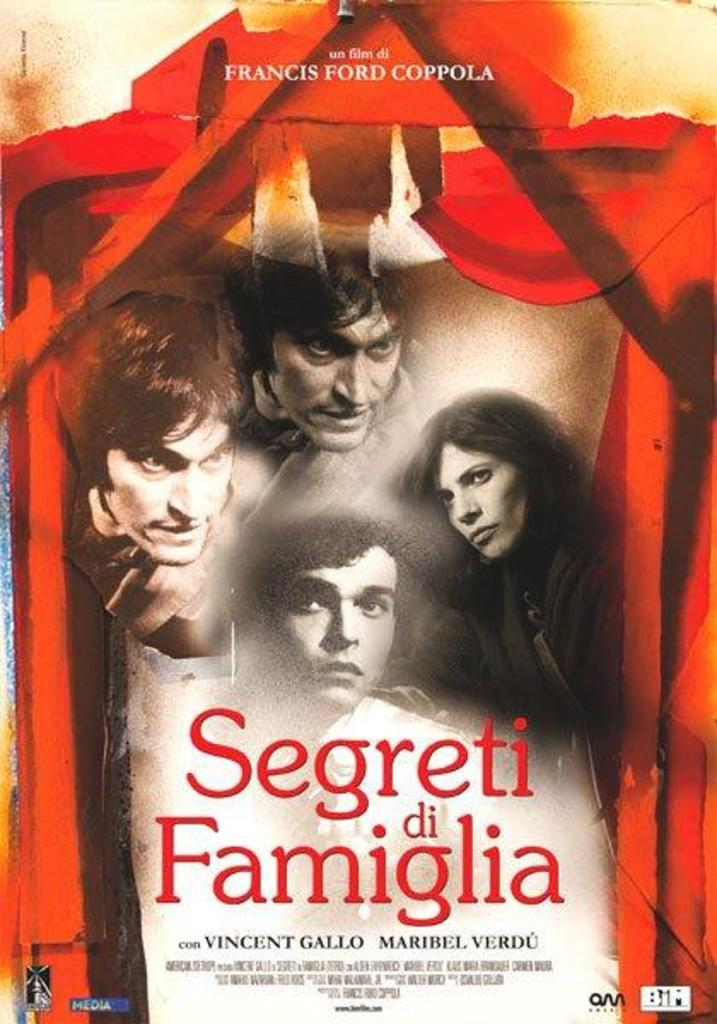<image>
Provide a brief description of the given image. The cover to the movie Segreti di Famiglia. 